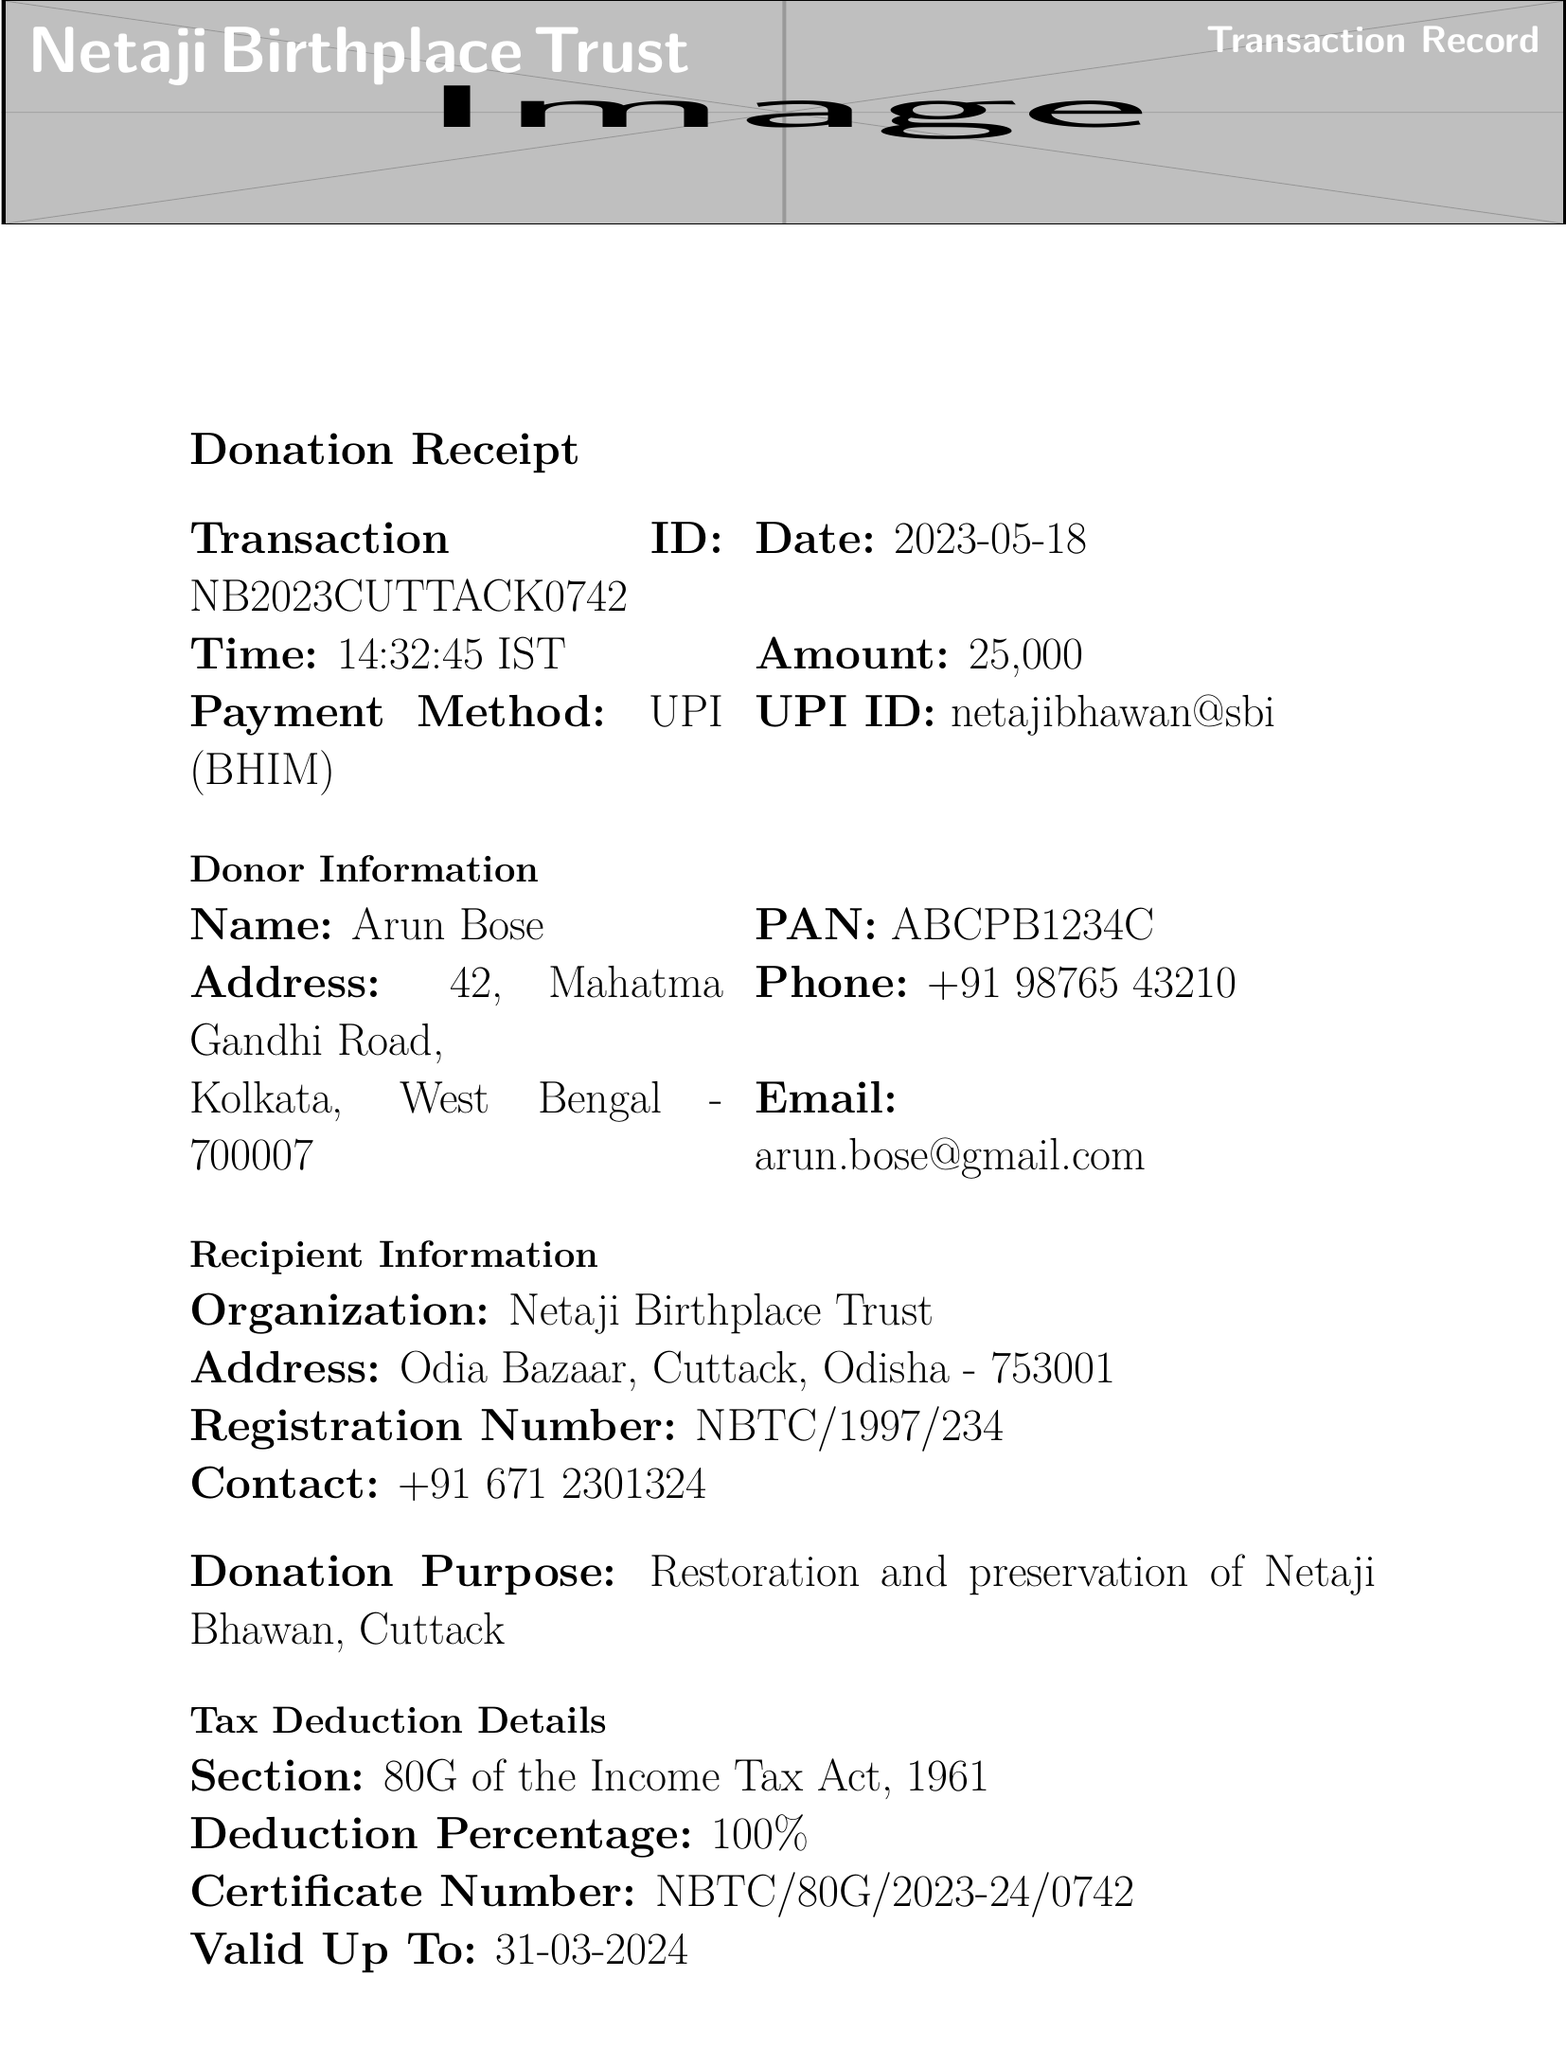What is the transaction ID? The transaction ID is a unique identifier for this donation record, specified in the document.
Answer: NB2023CUTTACK0742 When was the donation made? The date of the transaction is clearly mentioned in the document, indicating when the donation occurred.
Answer: 2023-05-18 What is the amount donated? The donation amount is explicitly stated in the document, showing the financial contribution made.
Answer: ₹25,000 Who is the donor? The document mentions the name of the individual who made the donation, which is crucial information.
Answer: Arun Bose What percentage deduction is available for tax? The document specifies the percentage of deduction available under the Income Tax Act for this donation.
Answer: 100% What is the purpose of the donation? The purpose is explicitly stated in the document, describing how the funds will be used.
Answer: Restoration and preservation of Netaji Bhawan, Cuttack What is the certificate number for tax deduction? The document provides the certificate number associated with the tax deduction claim.
Answer: NBTC/80G/2023-24/0742 What benefits does the donor receive? The document lists the benefits available to the donor in recognition of their contribution.
Answer: Free entry to Netaji Bhawan for one year, Invitation to annual Netaji Jayanti celebration at the premises, Donor's name displayed on the 'Wall of Patriots' at the museum What is the estimated cost of the restoration project? The document mentions the estimated financial requirement for the ongoing restoration project.
Answer: ₹2.5 crore 